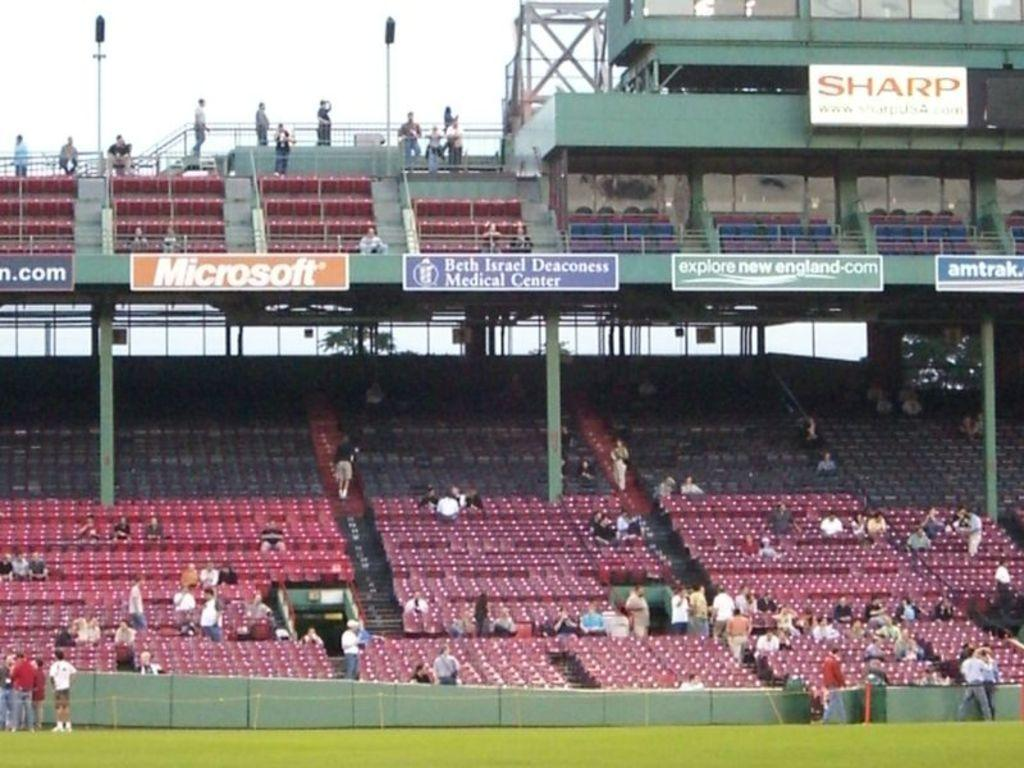<image>
Describe the image concisely. A sparsely populated stadium displays ads for Microsoft and Sharp. 